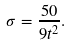<formula> <loc_0><loc_0><loc_500><loc_500>\sigma = \frac { 5 0 } { 9 t ^ { 2 } } .</formula> 